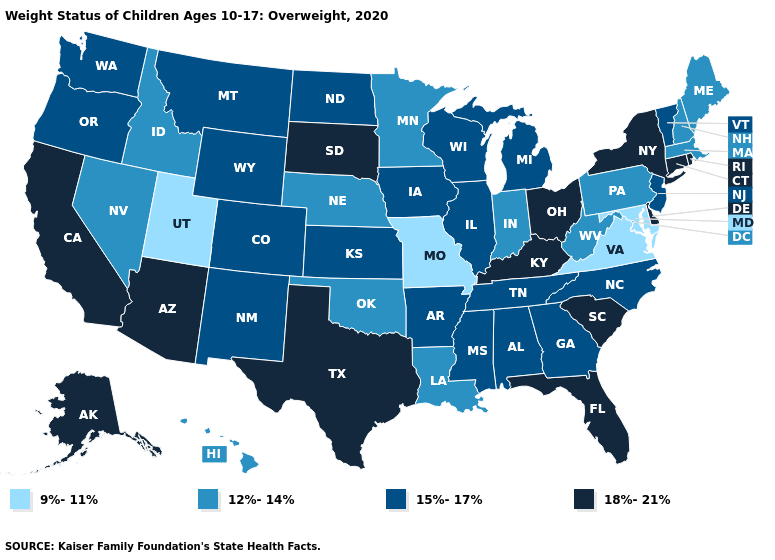Name the states that have a value in the range 15%-17%?
Concise answer only. Alabama, Arkansas, Colorado, Georgia, Illinois, Iowa, Kansas, Michigan, Mississippi, Montana, New Jersey, New Mexico, North Carolina, North Dakota, Oregon, Tennessee, Vermont, Washington, Wisconsin, Wyoming. Does Kentucky have the same value as Ohio?
Quick response, please. Yes. Which states have the highest value in the USA?
Write a very short answer. Alaska, Arizona, California, Connecticut, Delaware, Florida, Kentucky, New York, Ohio, Rhode Island, South Carolina, South Dakota, Texas. Does the first symbol in the legend represent the smallest category?
Concise answer only. Yes. Among the states that border Colorado , which have the lowest value?
Answer briefly. Utah. What is the value of Washington?
Keep it brief. 15%-17%. What is the value of Kansas?
Short answer required. 15%-17%. Does Ohio have the lowest value in the USA?
Give a very brief answer. No. Among the states that border Virginia , does Kentucky have the highest value?
Concise answer only. Yes. Does Washington have the highest value in the West?
Short answer required. No. What is the highest value in the South ?
Concise answer only. 18%-21%. Which states have the highest value in the USA?
Quick response, please. Alaska, Arizona, California, Connecticut, Delaware, Florida, Kentucky, New York, Ohio, Rhode Island, South Carolina, South Dakota, Texas. Among the states that border Utah , does Arizona have the highest value?
Keep it brief. Yes. Does Wyoming have the same value as Colorado?
Concise answer only. Yes. Does the first symbol in the legend represent the smallest category?
Be succinct. Yes. 